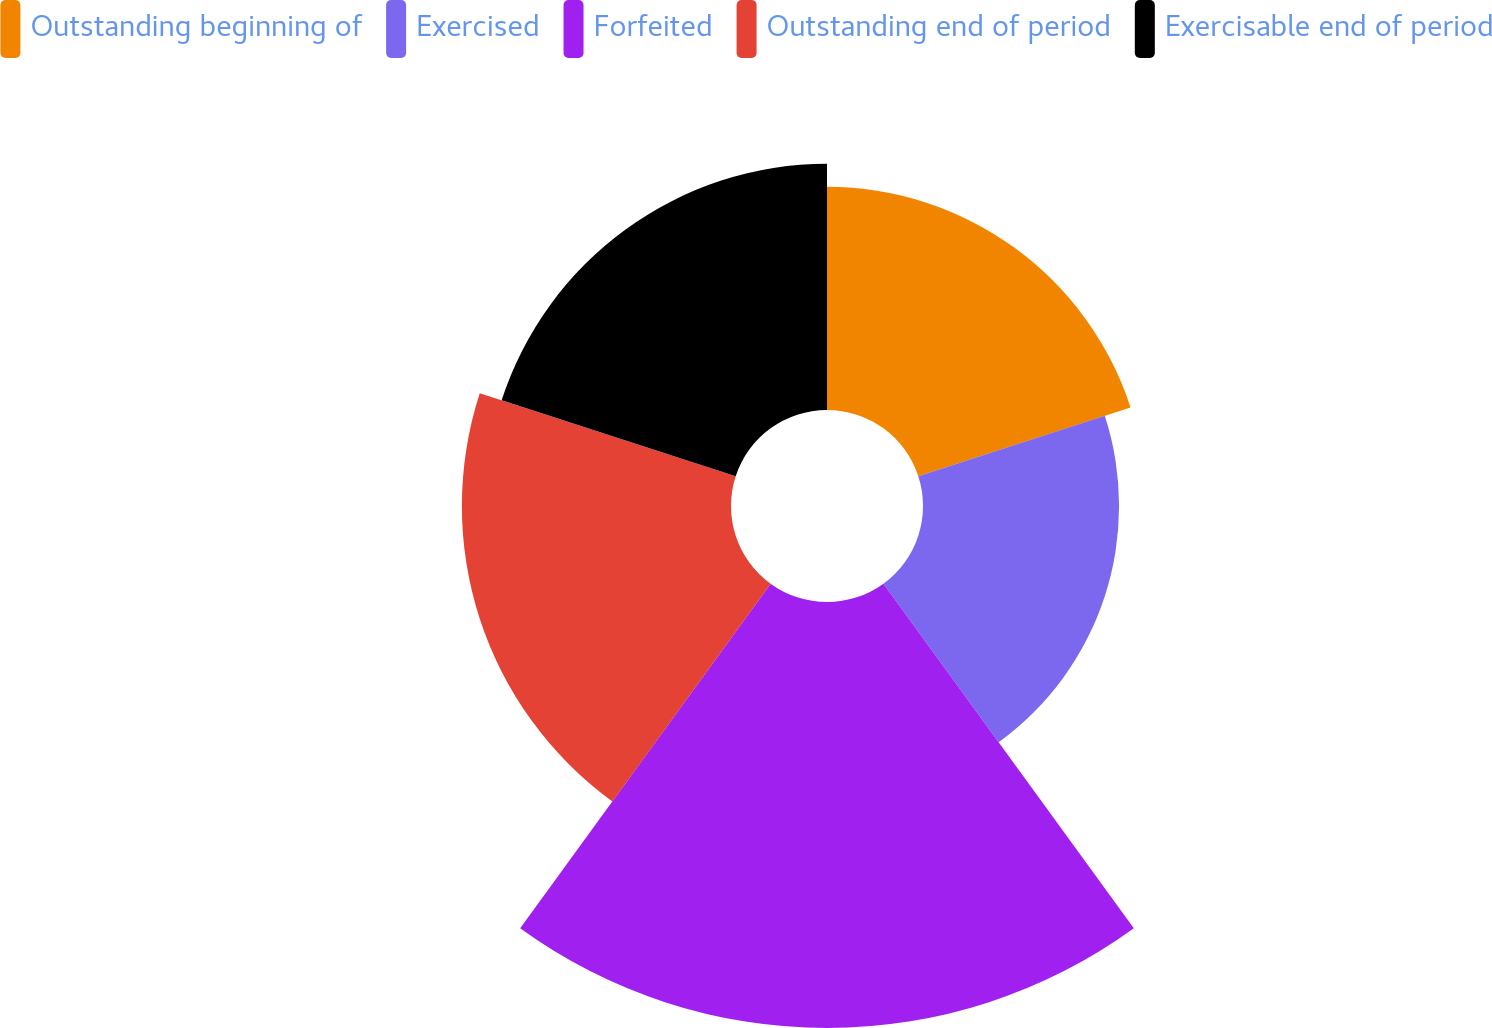Convert chart. <chart><loc_0><loc_0><loc_500><loc_500><pie_chart><fcel>Outstanding beginning of<fcel>Exercised<fcel>Forfeited<fcel>Outstanding end of period<fcel>Exercisable end of period<nl><fcel>16.4%<fcel>14.41%<fcel>31.31%<fcel>19.78%<fcel>18.09%<nl></chart> 